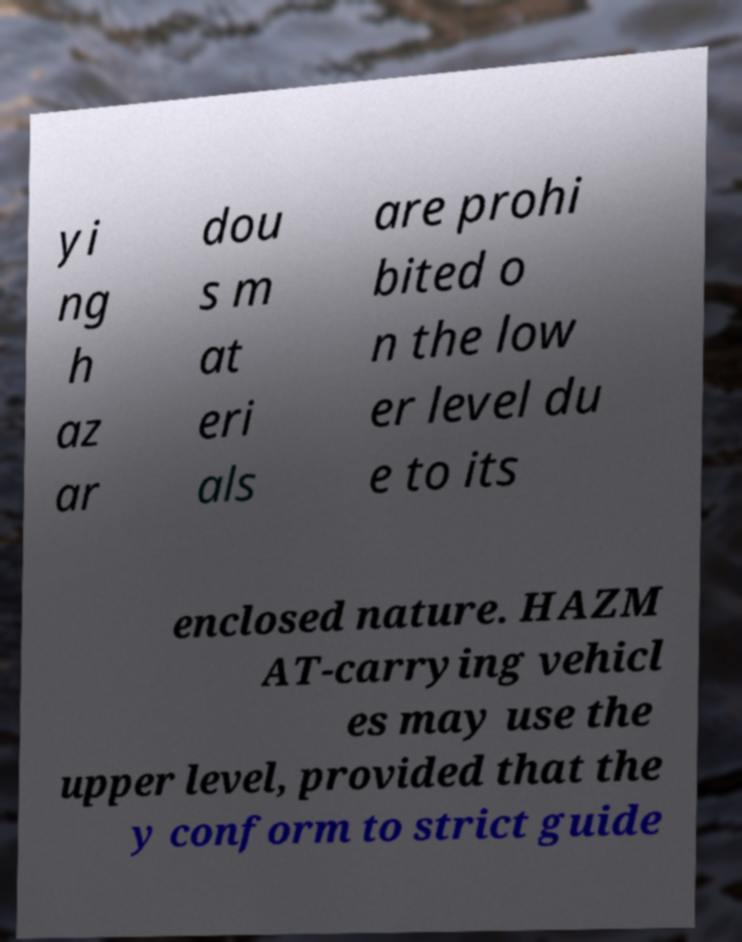Could you assist in decoding the text presented in this image and type it out clearly? yi ng h az ar dou s m at eri als are prohi bited o n the low er level du e to its enclosed nature. HAZM AT-carrying vehicl es may use the upper level, provided that the y conform to strict guide 